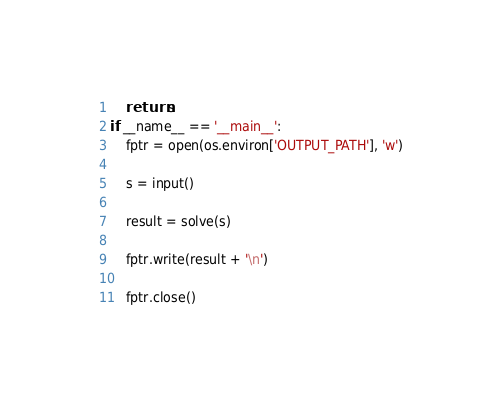<code> <loc_0><loc_0><loc_500><loc_500><_Python_>    return s
if __name__ == '__main__':
    fptr = open(os.environ['OUTPUT_PATH'], 'w')

    s = input()

    result = solve(s)

    fptr.write(result + '\n')

    fptr.close()
</code> 